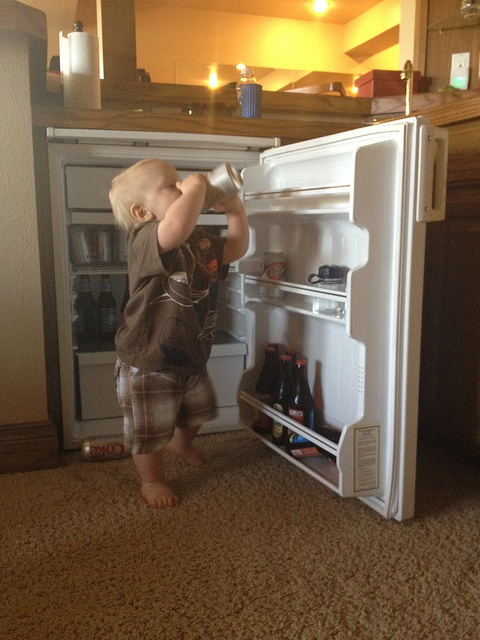Describe the objects in this image and their specific colors. I can see refrigerator in gray, black, darkgray, and lightgray tones, people in gray, black, and maroon tones, bottle in gray, black, maroon, and navy tones, bottle in gray and maroon tones, and bottle in black, brown, and gray tones in this image. 